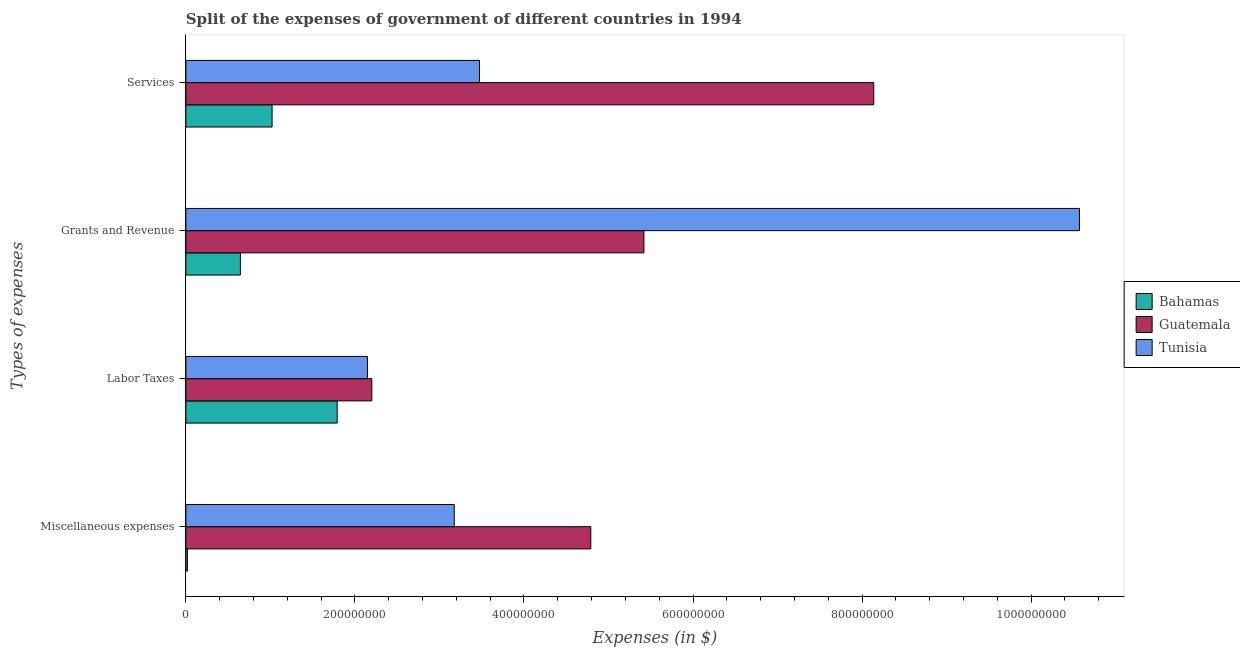Are the number of bars on each tick of the Y-axis equal?
Give a very brief answer. Yes. How many bars are there on the 1st tick from the top?
Your answer should be very brief. 3. What is the label of the 2nd group of bars from the top?
Your answer should be compact. Grants and Revenue. What is the amount spent on labor taxes in Tunisia?
Provide a short and direct response. 2.15e+08. Across all countries, what is the maximum amount spent on grants and revenue?
Give a very brief answer. 1.06e+09. Across all countries, what is the minimum amount spent on labor taxes?
Offer a terse response. 1.79e+08. In which country was the amount spent on services maximum?
Give a very brief answer. Guatemala. In which country was the amount spent on grants and revenue minimum?
Your answer should be very brief. Bahamas. What is the total amount spent on services in the graph?
Make the answer very short. 1.26e+09. What is the difference between the amount spent on miscellaneous expenses in Bahamas and that in Tunisia?
Keep it short and to the point. -3.16e+08. What is the difference between the amount spent on miscellaneous expenses in Tunisia and the amount spent on labor taxes in Bahamas?
Ensure brevity in your answer.  1.38e+08. What is the average amount spent on miscellaneous expenses per country?
Ensure brevity in your answer.  2.66e+08. What is the difference between the amount spent on grants and revenue and amount spent on miscellaneous expenses in Guatemala?
Your response must be concise. 6.28e+07. What is the ratio of the amount spent on labor taxes in Guatemala to that in Bahamas?
Provide a succinct answer. 1.23. Is the amount spent on labor taxes in Tunisia less than that in Guatemala?
Give a very brief answer. Yes. What is the difference between the highest and the second highest amount spent on miscellaneous expenses?
Give a very brief answer. 1.62e+08. What is the difference between the highest and the lowest amount spent on services?
Keep it short and to the point. 7.12e+08. In how many countries, is the amount spent on services greater than the average amount spent on services taken over all countries?
Offer a very short reply. 1. Is it the case that in every country, the sum of the amount spent on labor taxes and amount spent on grants and revenue is greater than the sum of amount spent on miscellaneous expenses and amount spent on services?
Give a very brief answer. No. What does the 1st bar from the top in Grants and Revenue represents?
Offer a terse response. Tunisia. What does the 1st bar from the bottom in Labor Taxes represents?
Your response must be concise. Bahamas. Is it the case that in every country, the sum of the amount spent on miscellaneous expenses and amount spent on labor taxes is greater than the amount spent on grants and revenue?
Keep it short and to the point. No. How many countries are there in the graph?
Provide a short and direct response. 3. What is the difference between two consecutive major ticks on the X-axis?
Your answer should be very brief. 2.00e+08. Where does the legend appear in the graph?
Keep it short and to the point. Center right. How many legend labels are there?
Make the answer very short. 3. What is the title of the graph?
Keep it short and to the point. Split of the expenses of government of different countries in 1994. Does "Kuwait" appear as one of the legend labels in the graph?
Offer a terse response. No. What is the label or title of the X-axis?
Keep it short and to the point. Expenses (in $). What is the label or title of the Y-axis?
Ensure brevity in your answer.  Types of expenses. What is the Expenses (in $) of Bahamas in Miscellaneous expenses?
Keep it short and to the point. 1.80e+06. What is the Expenses (in $) in Guatemala in Miscellaneous expenses?
Provide a succinct answer. 4.79e+08. What is the Expenses (in $) in Tunisia in Miscellaneous expenses?
Offer a terse response. 3.18e+08. What is the Expenses (in $) of Bahamas in Labor Taxes?
Offer a terse response. 1.79e+08. What is the Expenses (in $) in Guatemala in Labor Taxes?
Ensure brevity in your answer.  2.20e+08. What is the Expenses (in $) of Tunisia in Labor Taxes?
Provide a short and direct response. 2.15e+08. What is the Expenses (in $) of Bahamas in Grants and Revenue?
Make the answer very short. 6.45e+07. What is the Expenses (in $) in Guatemala in Grants and Revenue?
Give a very brief answer. 5.42e+08. What is the Expenses (in $) of Tunisia in Grants and Revenue?
Give a very brief answer. 1.06e+09. What is the Expenses (in $) in Bahamas in Services?
Your response must be concise. 1.02e+08. What is the Expenses (in $) in Guatemala in Services?
Make the answer very short. 8.14e+08. What is the Expenses (in $) of Tunisia in Services?
Keep it short and to the point. 3.47e+08. Across all Types of expenses, what is the maximum Expenses (in $) in Bahamas?
Offer a very short reply. 1.79e+08. Across all Types of expenses, what is the maximum Expenses (in $) in Guatemala?
Offer a terse response. 8.14e+08. Across all Types of expenses, what is the maximum Expenses (in $) in Tunisia?
Offer a very short reply. 1.06e+09. Across all Types of expenses, what is the minimum Expenses (in $) of Bahamas?
Ensure brevity in your answer.  1.80e+06. Across all Types of expenses, what is the minimum Expenses (in $) of Guatemala?
Provide a succinct answer. 2.20e+08. Across all Types of expenses, what is the minimum Expenses (in $) of Tunisia?
Ensure brevity in your answer.  2.15e+08. What is the total Expenses (in $) in Bahamas in the graph?
Make the answer very short. 3.47e+08. What is the total Expenses (in $) of Guatemala in the graph?
Provide a short and direct response. 2.05e+09. What is the total Expenses (in $) of Tunisia in the graph?
Provide a succinct answer. 1.94e+09. What is the difference between the Expenses (in $) of Bahamas in Miscellaneous expenses and that in Labor Taxes?
Your answer should be compact. -1.77e+08. What is the difference between the Expenses (in $) in Guatemala in Miscellaneous expenses and that in Labor Taxes?
Your response must be concise. 2.59e+08. What is the difference between the Expenses (in $) of Tunisia in Miscellaneous expenses and that in Labor Taxes?
Ensure brevity in your answer.  1.03e+08. What is the difference between the Expenses (in $) in Bahamas in Miscellaneous expenses and that in Grants and Revenue?
Make the answer very short. -6.27e+07. What is the difference between the Expenses (in $) in Guatemala in Miscellaneous expenses and that in Grants and Revenue?
Your answer should be compact. -6.28e+07. What is the difference between the Expenses (in $) of Tunisia in Miscellaneous expenses and that in Grants and Revenue?
Ensure brevity in your answer.  -7.40e+08. What is the difference between the Expenses (in $) in Bahamas in Miscellaneous expenses and that in Services?
Give a very brief answer. -1.00e+08. What is the difference between the Expenses (in $) in Guatemala in Miscellaneous expenses and that in Services?
Make the answer very short. -3.35e+08. What is the difference between the Expenses (in $) of Tunisia in Miscellaneous expenses and that in Services?
Ensure brevity in your answer.  -2.99e+07. What is the difference between the Expenses (in $) in Bahamas in Labor Taxes and that in Grants and Revenue?
Ensure brevity in your answer.  1.14e+08. What is the difference between the Expenses (in $) of Guatemala in Labor Taxes and that in Grants and Revenue?
Your answer should be very brief. -3.22e+08. What is the difference between the Expenses (in $) of Tunisia in Labor Taxes and that in Grants and Revenue?
Provide a succinct answer. -8.42e+08. What is the difference between the Expenses (in $) in Bahamas in Labor Taxes and that in Services?
Provide a succinct answer. 7.70e+07. What is the difference between the Expenses (in $) of Guatemala in Labor Taxes and that in Services?
Offer a very short reply. -5.94e+08. What is the difference between the Expenses (in $) of Tunisia in Labor Taxes and that in Services?
Offer a terse response. -1.33e+08. What is the difference between the Expenses (in $) of Bahamas in Grants and Revenue and that in Services?
Give a very brief answer. -3.75e+07. What is the difference between the Expenses (in $) in Guatemala in Grants and Revenue and that in Services?
Offer a very short reply. -2.72e+08. What is the difference between the Expenses (in $) of Tunisia in Grants and Revenue and that in Services?
Provide a short and direct response. 7.10e+08. What is the difference between the Expenses (in $) in Bahamas in Miscellaneous expenses and the Expenses (in $) in Guatemala in Labor Taxes?
Offer a very short reply. -2.18e+08. What is the difference between the Expenses (in $) in Bahamas in Miscellaneous expenses and the Expenses (in $) in Tunisia in Labor Taxes?
Keep it short and to the point. -2.13e+08. What is the difference between the Expenses (in $) in Guatemala in Miscellaneous expenses and the Expenses (in $) in Tunisia in Labor Taxes?
Your answer should be compact. 2.64e+08. What is the difference between the Expenses (in $) in Bahamas in Miscellaneous expenses and the Expenses (in $) in Guatemala in Grants and Revenue?
Ensure brevity in your answer.  -5.40e+08. What is the difference between the Expenses (in $) in Bahamas in Miscellaneous expenses and the Expenses (in $) in Tunisia in Grants and Revenue?
Give a very brief answer. -1.06e+09. What is the difference between the Expenses (in $) in Guatemala in Miscellaneous expenses and the Expenses (in $) in Tunisia in Grants and Revenue?
Make the answer very short. -5.78e+08. What is the difference between the Expenses (in $) in Bahamas in Miscellaneous expenses and the Expenses (in $) in Guatemala in Services?
Keep it short and to the point. -8.12e+08. What is the difference between the Expenses (in $) in Bahamas in Miscellaneous expenses and the Expenses (in $) in Tunisia in Services?
Offer a very short reply. -3.46e+08. What is the difference between the Expenses (in $) of Guatemala in Miscellaneous expenses and the Expenses (in $) of Tunisia in Services?
Make the answer very short. 1.32e+08. What is the difference between the Expenses (in $) of Bahamas in Labor Taxes and the Expenses (in $) of Guatemala in Grants and Revenue?
Offer a terse response. -3.63e+08. What is the difference between the Expenses (in $) of Bahamas in Labor Taxes and the Expenses (in $) of Tunisia in Grants and Revenue?
Make the answer very short. -8.78e+08. What is the difference between the Expenses (in $) in Guatemala in Labor Taxes and the Expenses (in $) in Tunisia in Grants and Revenue?
Your answer should be very brief. -8.37e+08. What is the difference between the Expenses (in $) in Bahamas in Labor Taxes and the Expenses (in $) in Guatemala in Services?
Give a very brief answer. -6.35e+08. What is the difference between the Expenses (in $) of Bahamas in Labor Taxes and the Expenses (in $) of Tunisia in Services?
Make the answer very short. -1.68e+08. What is the difference between the Expenses (in $) of Guatemala in Labor Taxes and the Expenses (in $) of Tunisia in Services?
Keep it short and to the point. -1.27e+08. What is the difference between the Expenses (in $) of Bahamas in Grants and Revenue and the Expenses (in $) of Guatemala in Services?
Keep it short and to the point. -7.49e+08. What is the difference between the Expenses (in $) of Bahamas in Grants and Revenue and the Expenses (in $) of Tunisia in Services?
Provide a short and direct response. -2.83e+08. What is the difference between the Expenses (in $) of Guatemala in Grants and Revenue and the Expenses (in $) of Tunisia in Services?
Offer a terse response. 1.95e+08. What is the average Expenses (in $) of Bahamas per Types of expenses?
Provide a short and direct response. 8.68e+07. What is the average Expenses (in $) in Guatemala per Types of expenses?
Give a very brief answer. 5.14e+08. What is the average Expenses (in $) in Tunisia per Types of expenses?
Your answer should be compact. 4.84e+08. What is the difference between the Expenses (in $) in Bahamas and Expenses (in $) in Guatemala in Miscellaneous expenses?
Your response must be concise. -4.77e+08. What is the difference between the Expenses (in $) of Bahamas and Expenses (in $) of Tunisia in Miscellaneous expenses?
Provide a short and direct response. -3.16e+08. What is the difference between the Expenses (in $) in Guatemala and Expenses (in $) in Tunisia in Miscellaneous expenses?
Make the answer very short. 1.62e+08. What is the difference between the Expenses (in $) in Bahamas and Expenses (in $) in Guatemala in Labor Taxes?
Provide a short and direct response. -4.10e+07. What is the difference between the Expenses (in $) in Bahamas and Expenses (in $) in Tunisia in Labor Taxes?
Offer a terse response. -3.58e+07. What is the difference between the Expenses (in $) of Guatemala and Expenses (in $) of Tunisia in Labor Taxes?
Offer a terse response. 5.18e+06. What is the difference between the Expenses (in $) in Bahamas and Expenses (in $) in Guatemala in Grants and Revenue?
Your response must be concise. -4.77e+08. What is the difference between the Expenses (in $) of Bahamas and Expenses (in $) of Tunisia in Grants and Revenue?
Offer a very short reply. -9.93e+08. What is the difference between the Expenses (in $) in Guatemala and Expenses (in $) in Tunisia in Grants and Revenue?
Give a very brief answer. -5.15e+08. What is the difference between the Expenses (in $) in Bahamas and Expenses (in $) in Guatemala in Services?
Provide a succinct answer. -7.12e+08. What is the difference between the Expenses (in $) of Bahamas and Expenses (in $) of Tunisia in Services?
Your response must be concise. -2.45e+08. What is the difference between the Expenses (in $) of Guatemala and Expenses (in $) of Tunisia in Services?
Make the answer very short. 4.66e+08. What is the ratio of the Expenses (in $) of Bahamas in Miscellaneous expenses to that in Labor Taxes?
Your answer should be compact. 0.01. What is the ratio of the Expenses (in $) of Guatemala in Miscellaneous expenses to that in Labor Taxes?
Your response must be concise. 2.18. What is the ratio of the Expenses (in $) in Tunisia in Miscellaneous expenses to that in Labor Taxes?
Ensure brevity in your answer.  1.48. What is the ratio of the Expenses (in $) in Bahamas in Miscellaneous expenses to that in Grants and Revenue?
Offer a terse response. 0.03. What is the ratio of the Expenses (in $) in Guatemala in Miscellaneous expenses to that in Grants and Revenue?
Ensure brevity in your answer.  0.88. What is the ratio of the Expenses (in $) of Tunisia in Miscellaneous expenses to that in Grants and Revenue?
Give a very brief answer. 0.3. What is the ratio of the Expenses (in $) in Bahamas in Miscellaneous expenses to that in Services?
Make the answer very short. 0.02. What is the ratio of the Expenses (in $) in Guatemala in Miscellaneous expenses to that in Services?
Provide a short and direct response. 0.59. What is the ratio of the Expenses (in $) of Tunisia in Miscellaneous expenses to that in Services?
Your answer should be compact. 0.91. What is the ratio of the Expenses (in $) of Bahamas in Labor Taxes to that in Grants and Revenue?
Offer a very short reply. 2.78. What is the ratio of the Expenses (in $) in Guatemala in Labor Taxes to that in Grants and Revenue?
Offer a terse response. 0.41. What is the ratio of the Expenses (in $) in Tunisia in Labor Taxes to that in Grants and Revenue?
Offer a terse response. 0.2. What is the ratio of the Expenses (in $) of Bahamas in Labor Taxes to that in Services?
Provide a short and direct response. 1.75. What is the ratio of the Expenses (in $) of Guatemala in Labor Taxes to that in Services?
Offer a very short reply. 0.27. What is the ratio of the Expenses (in $) in Tunisia in Labor Taxes to that in Services?
Ensure brevity in your answer.  0.62. What is the ratio of the Expenses (in $) of Bahamas in Grants and Revenue to that in Services?
Keep it short and to the point. 0.63. What is the ratio of the Expenses (in $) of Guatemala in Grants and Revenue to that in Services?
Your response must be concise. 0.67. What is the ratio of the Expenses (in $) in Tunisia in Grants and Revenue to that in Services?
Your answer should be very brief. 3.04. What is the difference between the highest and the second highest Expenses (in $) in Bahamas?
Offer a very short reply. 7.70e+07. What is the difference between the highest and the second highest Expenses (in $) in Guatemala?
Offer a very short reply. 2.72e+08. What is the difference between the highest and the second highest Expenses (in $) in Tunisia?
Keep it short and to the point. 7.10e+08. What is the difference between the highest and the lowest Expenses (in $) of Bahamas?
Your answer should be very brief. 1.77e+08. What is the difference between the highest and the lowest Expenses (in $) of Guatemala?
Provide a short and direct response. 5.94e+08. What is the difference between the highest and the lowest Expenses (in $) of Tunisia?
Give a very brief answer. 8.42e+08. 